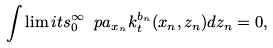Convert formula to latex. <formula><loc_0><loc_0><loc_500><loc_500>\int \lim i t s _ { 0 } ^ { \infty } \ p a _ { x _ { n } } k ^ { b _ { n } } _ { t } ( x _ { n } , z _ { n } ) d z _ { n } = 0 ,</formula> 